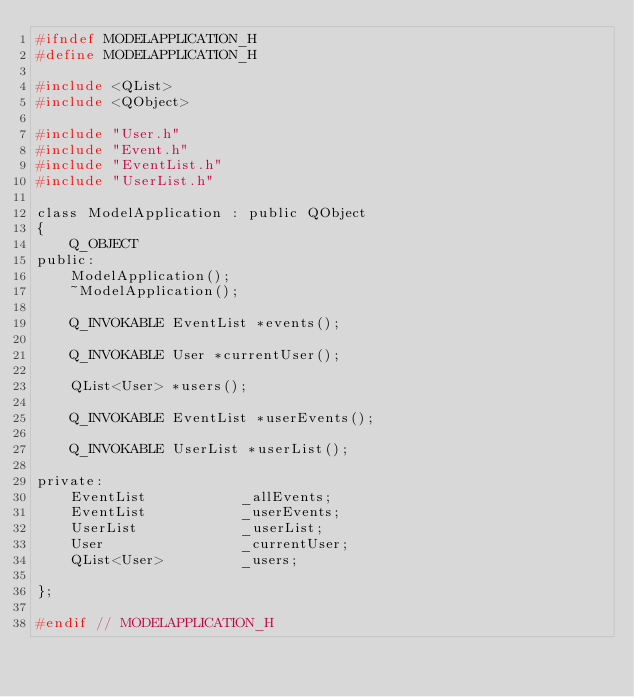<code> <loc_0><loc_0><loc_500><loc_500><_C_>#ifndef MODELAPPLICATION_H
#define MODELAPPLICATION_H

#include <QList>
#include <QObject>

#include "User.h"
#include "Event.h"
#include "EventList.h"
#include "UserList.h"

class ModelApplication : public QObject
{
    Q_OBJECT
public:
    ModelApplication();
    ~ModelApplication();

    Q_INVOKABLE EventList *events();

    Q_INVOKABLE User *currentUser();

    QList<User> *users();

    Q_INVOKABLE EventList *userEvents();

    Q_INVOKABLE UserList *userList();

private:
    EventList           _allEvents;
    EventList           _userEvents;
    UserList            _userList;
    User                _currentUser;
    QList<User>         _users;

};

#endif // MODELAPPLICATION_H
</code> 